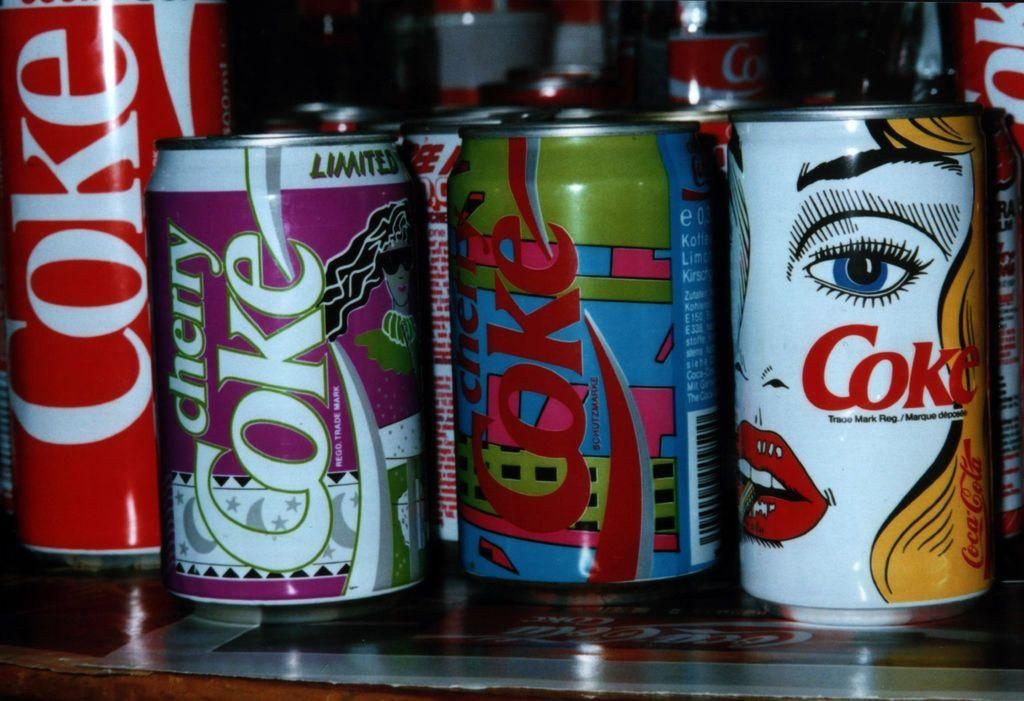<image>
Present a compact description of the photo's key features. Several cans of coke with different colors on them such as cherry coke. 